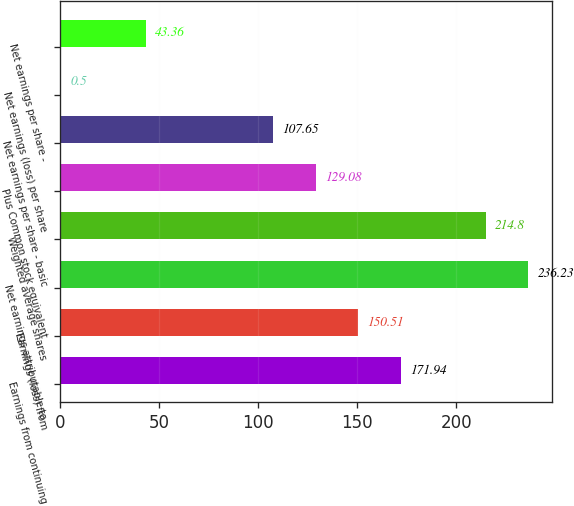Convert chart to OTSL. <chart><loc_0><loc_0><loc_500><loc_500><bar_chart><fcel>Earnings from continuing<fcel>Earnings (loss) from<fcel>Net earnings attributable to<fcel>Weighted average shares<fcel>Plus Common stock equivalent<fcel>Net earnings per share - basic<fcel>Net earnings (loss) per share<fcel>Net earnings per share -<nl><fcel>171.94<fcel>150.51<fcel>236.23<fcel>214.8<fcel>129.08<fcel>107.65<fcel>0.5<fcel>43.36<nl></chart> 